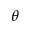<formula> <loc_0><loc_0><loc_500><loc_500>\theta</formula> 